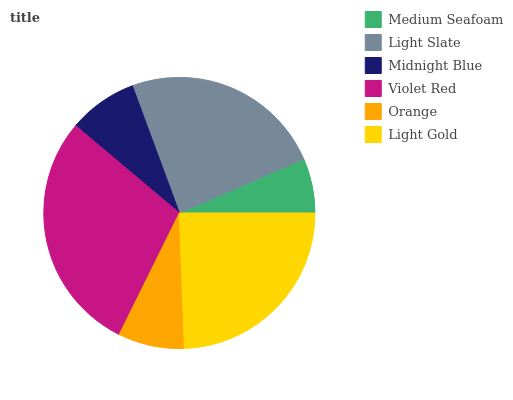Is Medium Seafoam the minimum?
Answer yes or no. Yes. Is Violet Red the maximum?
Answer yes or no. Yes. Is Light Slate the minimum?
Answer yes or no. No. Is Light Slate the maximum?
Answer yes or no. No. Is Light Slate greater than Medium Seafoam?
Answer yes or no. Yes. Is Medium Seafoam less than Light Slate?
Answer yes or no. Yes. Is Medium Seafoam greater than Light Slate?
Answer yes or no. No. Is Light Slate less than Medium Seafoam?
Answer yes or no. No. Is Light Slate the high median?
Answer yes or no. Yes. Is Midnight Blue the low median?
Answer yes or no. Yes. Is Orange the high median?
Answer yes or no. No. Is Orange the low median?
Answer yes or no. No. 